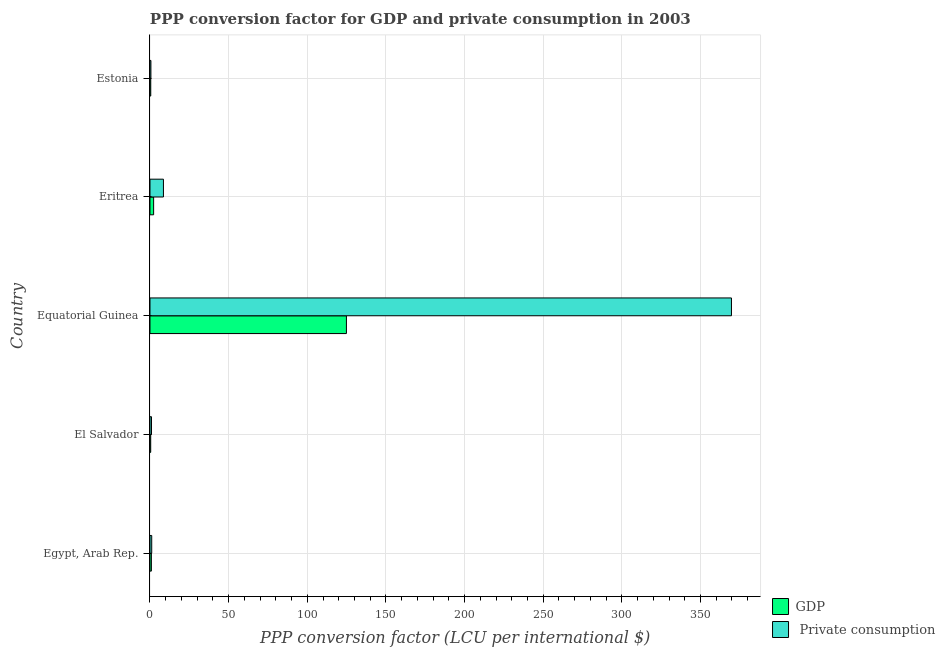How many different coloured bars are there?
Your answer should be very brief. 2. Are the number of bars on each tick of the Y-axis equal?
Offer a terse response. Yes. What is the label of the 4th group of bars from the top?
Offer a very short reply. El Salvador. What is the ppp conversion factor for gdp in Equatorial Guinea?
Your response must be concise. 124.88. Across all countries, what is the maximum ppp conversion factor for gdp?
Provide a succinct answer. 124.88. Across all countries, what is the minimum ppp conversion factor for private consumption?
Ensure brevity in your answer.  0.58. In which country was the ppp conversion factor for gdp maximum?
Keep it short and to the point. Equatorial Guinea. In which country was the ppp conversion factor for private consumption minimum?
Offer a terse response. Estonia. What is the total ppp conversion factor for private consumption in the graph?
Provide a succinct answer. 380.85. What is the difference between the ppp conversion factor for private consumption in Equatorial Guinea and that in Eritrea?
Give a very brief answer. 361.1. What is the difference between the ppp conversion factor for gdp in Equatorial Guinea and the ppp conversion factor for private consumption in El Salvador?
Offer a terse response. 123.92. What is the average ppp conversion factor for gdp per country?
Offer a very short reply. 25.8. What is the difference between the ppp conversion factor for private consumption and ppp conversion factor for gdp in Eritrea?
Your response must be concise. 6.24. What is the ratio of the ppp conversion factor for gdp in Egypt, Arab Rep. to that in Eritrea?
Ensure brevity in your answer.  0.38. Is the difference between the ppp conversion factor for private consumption in Equatorial Guinea and Estonia greater than the difference between the ppp conversion factor for gdp in Equatorial Guinea and Estonia?
Make the answer very short. Yes. What is the difference between the highest and the second highest ppp conversion factor for gdp?
Provide a short and direct response. 122.56. What is the difference between the highest and the lowest ppp conversion factor for private consumption?
Your answer should be compact. 369.08. In how many countries, is the ppp conversion factor for private consumption greater than the average ppp conversion factor for private consumption taken over all countries?
Ensure brevity in your answer.  1. Is the sum of the ppp conversion factor for private consumption in Egypt, Arab Rep. and Equatorial Guinea greater than the maximum ppp conversion factor for gdp across all countries?
Provide a short and direct response. Yes. What does the 2nd bar from the top in Eritrea represents?
Offer a terse response. GDP. What does the 2nd bar from the bottom in Egypt, Arab Rep. represents?
Provide a short and direct response.  Private consumption. How many bars are there?
Your answer should be compact. 10. What is the difference between two consecutive major ticks on the X-axis?
Offer a very short reply. 50. Does the graph contain grids?
Provide a succinct answer. Yes. What is the title of the graph?
Provide a succinct answer. PPP conversion factor for GDP and private consumption in 2003. Does "Investment in Telecom" appear as one of the legend labels in the graph?
Your answer should be very brief. No. What is the label or title of the X-axis?
Offer a very short reply. PPP conversion factor (LCU per international $). What is the label or title of the Y-axis?
Provide a succinct answer. Country. What is the PPP conversion factor (LCU per international $) of GDP in Egypt, Arab Rep.?
Your response must be concise. 0.88. What is the PPP conversion factor (LCU per international $) of  Private consumption in Egypt, Arab Rep.?
Make the answer very short. 1.1. What is the PPP conversion factor (LCU per international $) of GDP in El Salvador?
Provide a short and direct response. 0.45. What is the PPP conversion factor (LCU per international $) of  Private consumption in El Salvador?
Offer a terse response. 0.96. What is the PPP conversion factor (LCU per international $) of GDP in Equatorial Guinea?
Provide a succinct answer. 124.88. What is the PPP conversion factor (LCU per international $) of  Private consumption in Equatorial Guinea?
Provide a succinct answer. 369.66. What is the PPP conversion factor (LCU per international $) in GDP in Eritrea?
Your answer should be very brief. 2.32. What is the PPP conversion factor (LCU per international $) in  Private consumption in Eritrea?
Your response must be concise. 8.55. What is the PPP conversion factor (LCU per international $) of GDP in Estonia?
Give a very brief answer. 0.48. What is the PPP conversion factor (LCU per international $) of  Private consumption in Estonia?
Your response must be concise. 0.58. Across all countries, what is the maximum PPP conversion factor (LCU per international $) in GDP?
Offer a very short reply. 124.88. Across all countries, what is the maximum PPP conversion factor (LCU per international $) of  Private consumption?
Your response must be concise. 369.66. Across all countries, what is the minimum PPP conversion factor (LCU per international $) of GDP?
Provide a succinct answer. 0.45. Across all countries, what is the minimum PPP conversion factor (LCU per international $) in  Private consumption?
Give a very brief answer. 0.58. What is the total PPP conversion factor (LCU per international $) of GDP in the graph?
Provide a succinct answer. 129.01. What is the total PPP conversion factor (LCU per international $) in  Private consumption in the graph?
Your response must be concise. 380.85. What is the difference between the PPP conversion factor (LCU per international $) in GDP in Egypt, Arab Rep. and that in El Salvador?
Keep it short and to the point. 0.43. What is the difference between the PPP conversion factor (LCU per international $) in  Private consumption in Egypt, Arab Rep. and that in El Salvador?
Ensure brevity in your answer.  0.14. What is the difference between the PPP conversion factor (LCU per international $) in GDP in Egypt, Arab Rep. and that in Equatorial Guinea?
Provide a short and direct response. -124. What is the difference between the PPP conversion factor (LCU per international $) in  Private consumption in Egypt, Arab Rep. and that in Equatorial Guinea?
Ensure brevity in your answer.  -368.55. What is the difference between the PPP conversion factor (LCU per international $) in GDP in Egypt, Arab Rep. and that in Eritrea?
Your response must be concise. -1.44. What is the difference between the PPP conversion factor (LCU per international $) in  Private consumption in Egypt, Arab Rep. and that in Eritrea?
Provide a short and direct response. -7.45. What is the difference between the PPP conversion factor (LCU per international $) in GDP in Egypt, Arab Rep. and that in Estonia?
Your answer should be compact. 0.4. What is the difference between the PPP conversion factor (LCU per international $) in  Private consumption in Egypt, Arab Rep. and that in Estonia?
Your answer should be compact. 0.52. What is the difference between the PPP conversion factor (LCU per international $) of GDP in El Salvador and that in Equatorial Guinea?
Offer a very short reply. -124.43. What is the difference between the PPP conversion factor (LCU per international $) in  Private consumption in El Salvador and that in Equatorial Guinea?
Provide a short and direct response. -368.7. What is the difference between the PPP conversion factor (LCU per international $) in GDP in El Salvador and that in Eritrea?
Make the answer very short. -1.86. What is the difference between the PPP conversion factor (LCU per international $) in  Private consumption in El Salvador and that in Eritrea?
Make the answer very short. -7.6. What is the difference between the PPP conversion factor (LCU per international $) of GDP in El Salvador and that in Estonia?
Offer a terse response. -0.03. What is the difference between the PPP conversion factor (LCU per international $) of  Private consumption in El Salvador and that in Estonia?
Provide a succinct answer. 0.38. What is the difference between the PPP conversion factor (LCU per international $) of GDP in Equatorial Guinea and that in Eritrea?
Your response must be concise. 122.56. What is the difference between the PPP conversion factor (LCU per international $) of  Private consumption in Equatorial Guinea and that in Eritrea?
Provide a short and direct response. 361.1. What is the difference between the PPP conversion factor (LCU per international $) of GDP in Equatorial Guinea and that in Estonia?
Your answer should be very brief. 124.4. What is the difference between the PPP conversion factor (LCU per international $) of  Private consumption in Equatorial Guinea and that in Estonia?
Ensure brevity in your answer.  369.08. What is the difference between the PPP conversion factor (LCU per international $) of GDP in Eritrea and that in Estonia?
Keep it short and to the point. 1.84. What is the difference between the PPP conversion factor (LCU per international $) of  Private consumption in Eritrea and that in Estonia?
Offer a very short reply. 7.97. What is the difference between the PPP conversion factor (LCU per international $) in GDP in Egypt, Arab Rep. and the PPP conversion factor (LCU per international $) in  Private consumption in El Salvador?
Your response must be concise. -0.08. What is the difference between the PPP conversion factor (LCU per international $) of GDP in Egypt, Arab Rep. and the PPP conversion factor (LCU per international $) of  Private consumption in Equatorial Guinea?
Your answer should be compact. -368.78. What is the difference between the PPP conversion factor (LCU per international $) of GDP in Egypt, Arab Rep. and the PPP conversion factor (LCU per international $) of  Private consumption in Eritrea?
Your answer should be compact. -7.67. What is the difference between the PPP conversion factor (LCU per international $) in GDP in Egypt, Arab Rep. and the PPP conversion factor (LCU per international $) in  Private consumption in Estonia?
Make the answer very short. 0.3. What is the difference between the PPP conversion factor (LCU per international $) of GDP in El Salvador and the PPP conversion factor (LCU per international $) of  Private consumption in Equatorial Guinea?
Provide a succinct answer. -369.2. What is the difference between the PPP conversion factor (LCU per international $) of GDP in El Salvador and the PPP conversion factor (LCU per international $) of  Private consumption in Eritrea?
Offer a terse response. -8.1. What is the difference between the PPP conversion factor (LCU per international $) in GDP in El Salvador and the PPP conversion factor (LCU per international $) in  Private consumption in Estonia?
Make the answer very short. -0.13. What is the difference between the PPP conversion factor (LCU per international $) of GDP in Equatorial Guinea and the PPP conversion factor (LCU per international $) of  Private consumption in Eritrea?
Give a very brief answer. 116.33. What is the difference between the PPP conversion factor (LCU per international $) of GDP in Equatorial Guinea and the PPP conversion factor (LCU per international $) of  Private consumption in Estonia?
Offer a terse response. 124.3. What is the difference between the PPP conversion factor (LCU per international $) of GDP in Eritrea and the PPP conversion factor (LCU per international $) of  Private consumption in Estonia?
Make the answer very short. 1.74. What is the average PPP conversion factor (LCU per international $) of GDP per country?
Provide a succinct answer. 25.8. What is the average PPP conversion factor (LCU per international $) in  Private consumption per country?
Your response must be concise. 76.17. What is the difference between the PPP conversion factor (LCU per international $) in GDP and PPP conversion factor (LCU per international $) in  Private consumption in Egypt, Arab Rep.?
Provide a short and direct response. -0.22. What is the difference between the PPP conversion factor (LCU per international $) of GDP and PPP conversion factor (LCU per international $) of  Private consumption in El Salvador?
Offer a terse response. -0.51. What is the difference between the PPP conversion factor (LCU per international $) of GDP and PPP conversion factor (LCU per international $) of  Private consumption in Equatorial Guinea?
Keep it short and to the point. -244.78. What is the difference between the PPP conversion factor (LCU per international $) in GDP and PPP conversion factor (LCU per international $) in  Private consumption in Eritrea?
Provide a succinct answer. -6.24. What is the difference between the PPP conversion factor (LCU per international $) in GDP and PPP conversion factor (LCU per international $) in  Private consumption in Estonia?
Keep it short and to the point. -0.1. What is the ratio of the PPP conversion factor (LCU per international $) of GDP in Egypt, Arab Rep. to that in El Salvador?
Give a very brief answer. 1.95. What is the ratio of the PPP conversion factor (LCU per international $) in  Private consumption in Egypt, Arab Rep. to that in El Salvador?
Your answer should be very brief. 1.15. What is the ratio of the PPP conversion factor (LCU per international $) in GDP in Egypt, Arab Rep. to that in Equatorial Guinea?
Your answer should be compact. 0.01. What is the ratio of the PPP conversion factor (LCU per international $) in  Private consumption in Egypt, Arab Rep. to that in Equatorial Guinea?
Make the answer very short. 0. What is the ratio of the PPP conversion factor (LCU per international $) of GDP in Egypt, Arab Rep. to that in Eritrea?
Your answer should be compact. 0.38. What is the ratio of the PPP conversion factor (LCU per international $) of  Private consumption in Egypt, Arab Rep. to that in Eritrea?
Keep it short and to the point. 0.13. What is the ratio of the PPP conversion factor (LCU per international $) of GDP in Egypt, Arab Rep. to that in Estonia?
Ensure brevity in your answer.  1.83. What is the ratio of the PPP conversion factor (LCU per international $) in  Private consumption in Egypt, Arab Rep. to that in Estonia?
Ensure brevity in your answer.  1.9. What is the ratio of the PPP conversion factor (LCU per international $) of GDP in El Salvador to that in Equatorial Guinea?
Your answer should be very brief. 0. What is the ratio of the PPP conversion factor (LCU per international $) in  Private consumption in El Salvador to that in Equatorial Guinea?
Provide a succinct answer. 0. What is the ratio of the PPP conversion factor (LCU per international $) of GDP in El Salvador to that in Eritrea?
Offer a terse response. 0.19. What is the ratio of the PPP conversion factor (LCU per international $) of  Private consumption in El Salvador to that in Eritrea?
Your response must be concise. 0.11. What is the ratio of the PPP conversion factor (LCU per international $) in GDP in El Salvador to that in Estonia?
Your answer should be very brief. 0.94. What is the ratio of the PPP conversion factor (LCU per international $) in  Private consumption in El Salvador to that in Estonia?
Your answer should be very brief. 1.65. What is the ratio of the PPP conversion factor (LCU per international $) in GDP in Equatorial Guinea to that in Eritrea?
Your answer should be compact. 53.93. What is the ratio of the PPP conversion factor (LCU per international $) in  Private consumption in Equatorial Guinea to that in Eritrea?
Your answer should be very brief. 43.22. What is the ratio of the PPP conversion factor (LCU per international $) in GDP in Equatorial Guinea to that in Estonia?
Provide a short and direct response. 260.16. What is the ratio of the PPP conversion factor (LCU per international $) of  Private consumption in Equatorial Guinea to that in Estonia?
Your answer should be very brief. 637.14. What is the ratio of the PPP conversion factor (LCU per international $) of GDP in Eritrea to that in Estonia?
Make the answer very short. 4.82. What is the ratio of the PPP conversion factor (LCU per international $) in  Private consumption in Eritrea to that in Estonia?
Offer a very short reply. 14.74. What is the difference between the highest and the second highest PPP conversion factor (LCU per international $) in GDP?
Offer a very short reply. 122.56. What is the difference between the highest and the second highest PPP conversion factor (LCU per international $) of  Private consumption?
Your answer should be compact. 361.1. What is the difference between the highest and the lowest PPP conversion factor (LCU per international $) of GDP?
Make the answer very short. 124.43. What is the difference between the highest and the lowest PPP conversion factor (LCU per international $) of  Private consumption?
Make the answer very short. 369.08. 